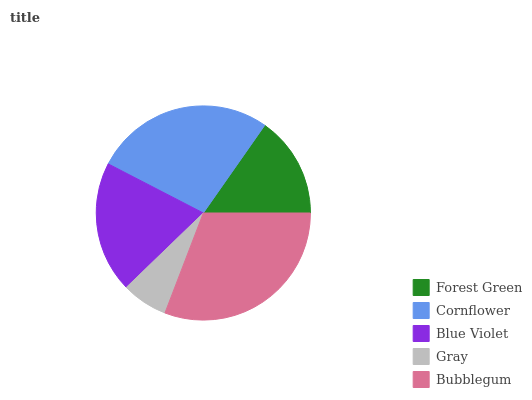Is Gray the minimum?
Answer yes or no. Yes. Is Bubblegum the maximum?
Answer yes or no. Yes. Is Cornflower the minimum?
Answer yes or no. No. Is Cornflower the maximum?
Answer yes or no. No. Is Cornflower greater than Forest Green?
Answer yes or no. Yes. Is Forest Green less than Cornflower?
Answer yes or no. Yes. Is Forest Green greater than Cornflower?
Answer yes or no. No. Is Cornflower less than Forest Green?
Answer yes or no. No. Is Blue Violet the high median?
Answer yes or no. Yes. Is Blue Violet the low median?
Answer yes or no. Yes. Is Bubblegum the high median?
Answer yes or no. No. Is Cornflower the low median?
Answer yes or no. No. 